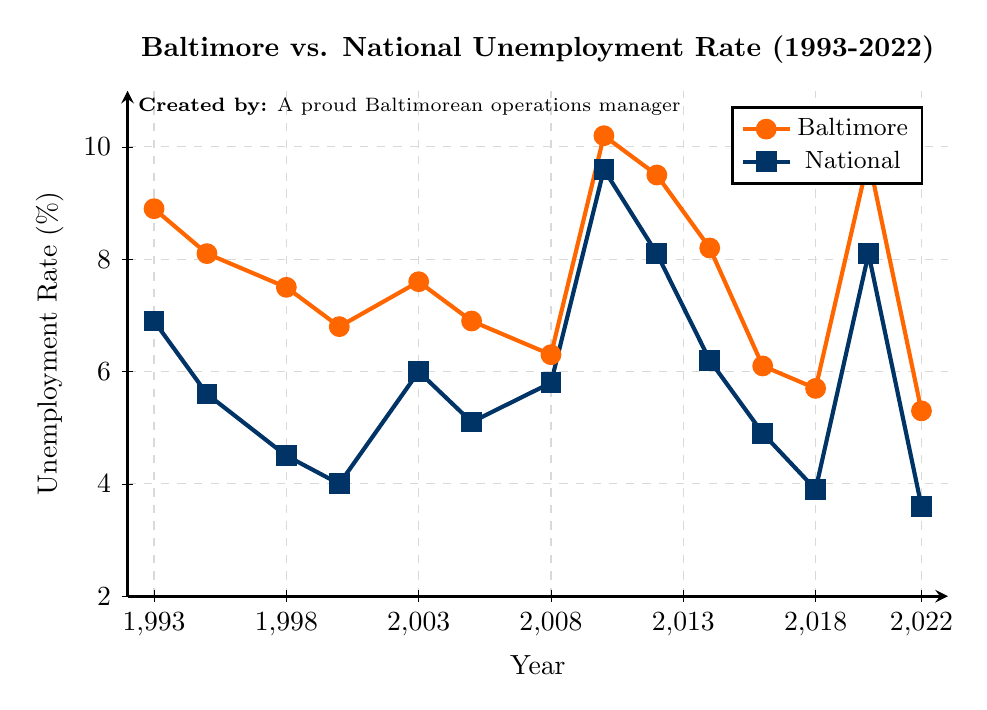What is the highest unemployment rate recorded in Baltimore over the years? The highest unemployment rate in Baltimore is the peak point of the orange line on the chart. The peak occurs in 2010 with a rate of 10.2%.
Answer: 10.2% How did the unemployment rates in Baltimore and the national average compare in 2020? In the year 2020, find the points on both lines corresponding to 2020. The Baltimore unemployment rate is 9.8%, and the national average is 8.1%.
Answer: Baltimore had an unemployment rate of 9.8%, and the national average was 8.1% What is the average national unemployment rate from 1993 to 2003? Identify the national unemployment rates from 1993, 1995, 1998, 2000, and 2003: (6.9, 5.6, 4.5, 4.0, 6.0). Sum these rates and divide by the number of years: (6.9 + 5.6 + 4.5 + 4.0 + 6.0) / 5.
Answer: 5.4% In which year did Baltimore have its lowest unemployment rate, and what was the rate? The lowest point on Baltimore's orange line is identified visually. The lowest rate is in 2022 with an unemployment rate of 5.3%.
Answer: 2022, 5.3% Was there any year when the unemployment rate in Baltimore was lower than the national average? Compare each data point of Baltimore's unemployment rate with the national rate. In all years, Baltimore's unemployment rate was higher than the national average.
Answer: No How did the unemployment rate change in Baltimore from 2018 to 2022? Locate the points for Baltimore's unemployment rate in 2018 and 2022. It drops from 5.7% in 2018 to 5.3% in 2022.
Answer: Decreased from 5.7% to 5.3% Which year shows the largest difference between the Baltimore and national unemployment rates? Calculate the differences between the Baltimore and national unemployment rates for each year and find the maximum difference. In 2010, the difference is the largest, with 10.2% (Baltimore) and 9.6% (National), a difference of 0.6%.
Answer: 2010 What is the general trend of the unemployment rates in Baltimore over the 30 years? By visually examining the trend of the orange line (Baltimore) over the years: There are fluctuations, but there is a general downward trend from 1993 to 2022.
Answer: General downward trend How do the unemployment rates in Baltimore and the nation compare during the economic peak around 2000? For the year 2000, find the unemployment rates for both Baltimore and the national average. Baltimore's rate is 6.8%, and the national rate is 4.0%.
Answer: Baltimore is higher: 6.8% vs. 4.0% 